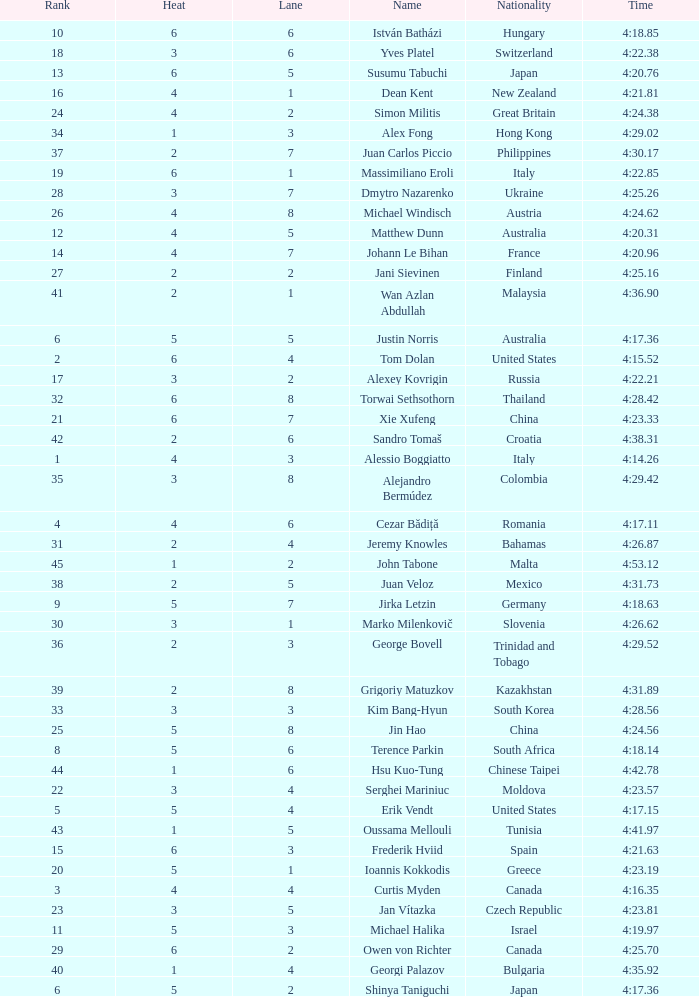Who was the 4 lane person from Canada? 4.0. 